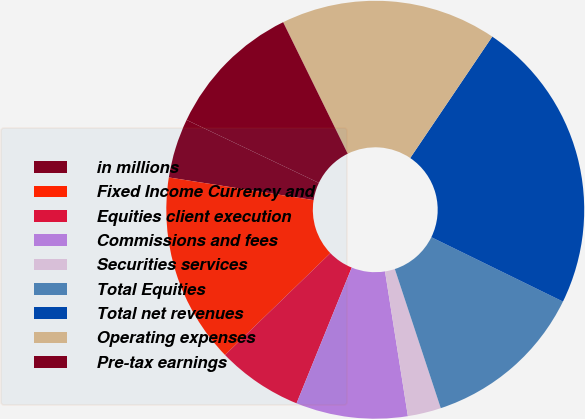Convert chart. <chart><loc_0><loc_0><loc_500><loc_500><pie_chart><fcel>in millions<fcel>Fixed Income Currency and<fcel>Equities client execution<fcel>Commissions and fees<fcel>Securities services<fcel>Total Equities<fcel>Total net revenues<fcel>Operating expenses<fcel>Pre-tax earnings<nl><fcel>4.6%<fcel>14.7%<fcel>6.62%<fcel>8.64%<fcel>2.58%<fcel>12.68%<fcel>22.78%<fcel>16.72%<fcel>10.66%<nl></chart> 